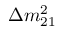Convert formula to latex. <formula><loc_0><loc_0><loc_500><loc_500>\Delta m _ { 2 1 } ^ { 2 }</formula> 